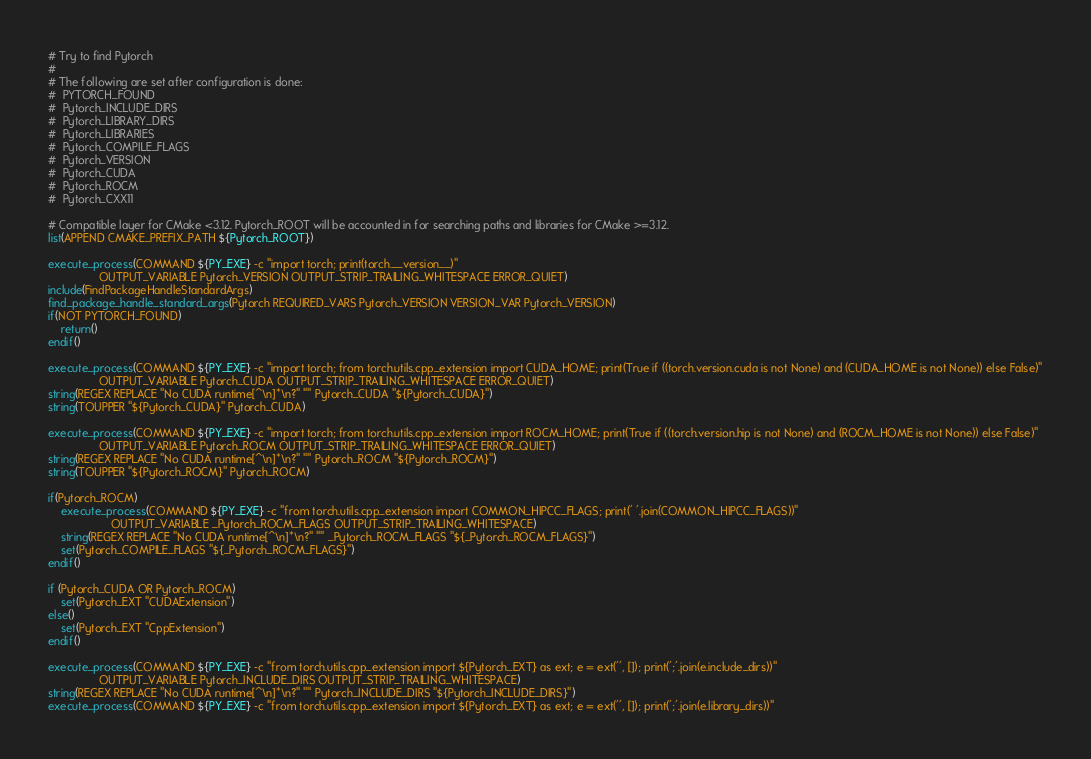Convert code to text. <code><loc_0><loc_0><loc_500><loc_500><_CMake_># Try to find Pytorch
#
# The following are set after configuration is done:
#  PYTORCH_FOUND
#  Pytorch_INCLUDE_DIRS
#  Pytorch_LIBRARY_DIRS
#  Pytorch_LIBRARIES
#  Pytorch_COMPILE_FLAGS
#  Pytorch_VERSION
#  Pytorch_CUDA
#  Pytorch_ROCM
#  Pytorch_CXX11

# Compatible layer for CMake <3.12. Pytorch_ROOT will be accounted in for searching paths and libraries for CMake >=3.12.
list(APPEND CMAKE_PREFIX_PATH ${Pytorch_ROOT})

execute_process(COMMAND ${PY_EXE} -c "import torch; print(torch.__version__)"
                OUTPUT_VARIABLE Pytorch_VERSION OUTPUT_STRIP_TRAILING_WHITESPACE ERROR_QUIET)
include(FindPackageHandleStandardArgs)
find_package_handle_standard_args(Pytorch REQUIRED_VARS Pytorch_VERSION VERSION_VAR Pytorch_VERSION)
if(NOT PYTORCH_FOUND)
    return()
endif()

execute_process(COMMAND ${PY_EXE} -c "import torch; from torch.utils.cpp_extension import CUDA_HOME; print(True if ((torch.version.cuda is not None) and (CUDA_HOME is not None)) else False)"
                OUTPUT_VARIABLE Pytorch_CUDA OUTPUT_STRIP_TRAILING_WHITESPACE ERROR_QUIET)
string(REGEX REPLACE "No CUDA runtime[^\n]*\n?" "" Pytorch_CUDA "${Pytorch_CUDA}")
string(TOUPPER "${Pytorch_CUDA}" Pytorch_CUDA)

execute_process(COMMAND ${PY_EXE} -c "import torch; from torch.utils.cpp_extension import ROCM_HOME; print(True if ((torch.version.hip is not None) and (ROCM_HOME is not None)) else False)"
                OUTPUT_VARIABLE Pytorch_ROCM OUTPUT_STRIP_TRAILING_WHITESPACE ERROR_QUIET)
string(REGEX REPLACE "No CUDA runtime[^\n]*\n?" "" Pytorch_ROCM "${Pytorch_ROCM}")
string(TOUPPER "${Pytorch_ROCM}" Pytorch_ROCM)

if(Pytorch_ROCM)
    execute_process(COMMAND ${PY_EXE} -c "from torch.utils.cpp_extension import COMMON_HIPCC_FLAGS; print(' '.join(COMMON_HIPCC_FLAGS))"
                    OUTPUT_VARIABLE _Pytorch_ROCM_FLAGS OUTPUT_STRIP_TRAILING_WHITESPACE)
    string(REGEX REPLACE "No CUDA runtime[^\n]*\n?" "" _Pytorch_ROCM_FLAGS "${_Pytorch_ROCM_FLAGS}")
    set(Pytorch_COMPILE_FLAGS "${_Pytorch_ROCM_FLAGS}")
endif()

if (Pytorch_CUDA OR Pytorch_ROCM)
    set(Pytorch_EXT "CUDAExtension")
else()
    set(Pytorch_EXT "CppExtension")
endif()

execute_process(COMMAND ${PY_EXE} -c "from torch.utils.cpp_extension import ${Pytorch_EXT} as ext; e = ext('', []); print(';'.join(e.include_dirs))"
                OUTPUT_VARIABLE Pytorch_INCLUDE_DIRS OUTPUT_STRIP_TRAILING_WHITESPACE)
string(REGEX REPLACE "No CUDA runtime[^\n]*\n?" "" Pytorch_INCLUDE_DIRS "${Pytorch_INCLUDE_DIRS}")
execute_process(COMMAND ${PY_EXE} -c "from torch.utils.cpp_extension import ${Pytorch_EXT} as ext; e = ext('', []); print(';'.join(e.library_dirs))"</code> 